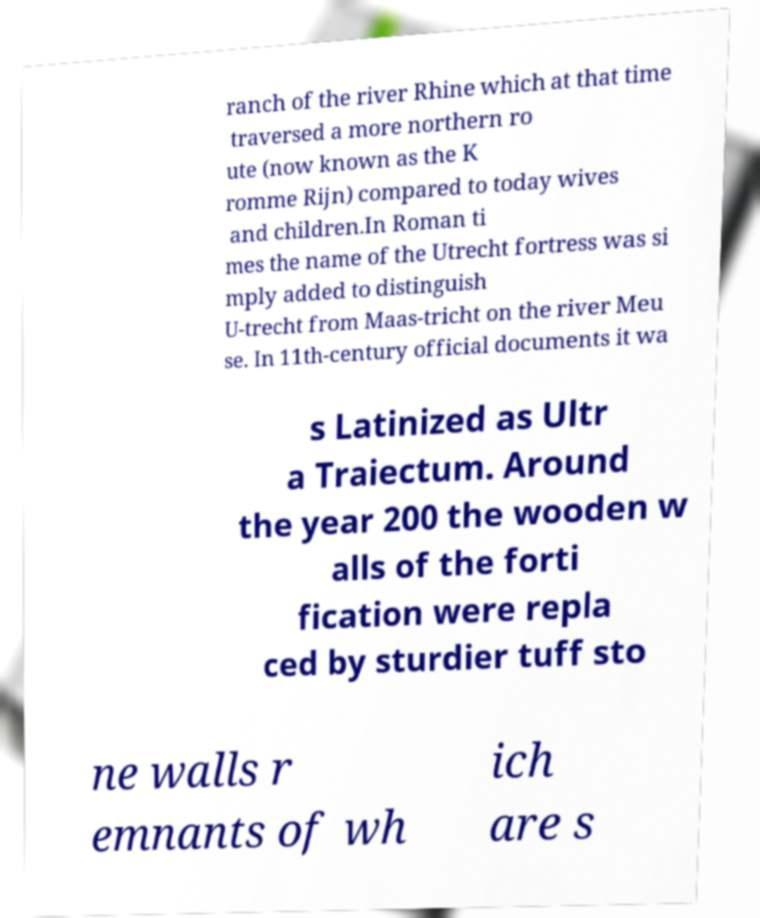What messages or text are displayed in this image? I need them in a readable, typed format. ranch of the river Rhine which at that time traversed a more northern ro ute (now known as the K romme Rijn) compared to today wives and children.In Roman ti mes the name of the Utrecht fortress was si mply added to distinguish U-trecht from Maas-tricht on the river Meu se. In 11th-century official documents it wa s Latinized as Ultr a Traiectum. Around the year 200 the wooden w alls of the forti fication were repla ced by sturdier tuff sto ne walls r emnants of wh ich are s 